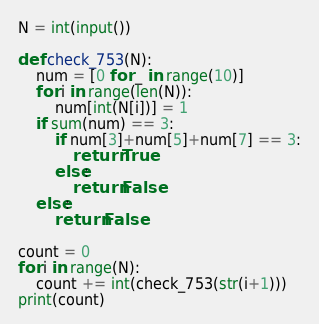<code> <loc_0><loc_0><loc_500><loc_500><_Python_>N = int(input())

def check_753(N):
    num = [0 for _ in range(10)]
    for i in range(len(N)):
        num[int(N[i])] = 1
    if sum(num) == 3:
        if num[3]+num[5]+num[7] == 3:
            return True
        else:
            return False
    else:
        return False

count = 0
for i in range(N):
    count += int(check_753(str(i+1)))
print(count)
</code> 